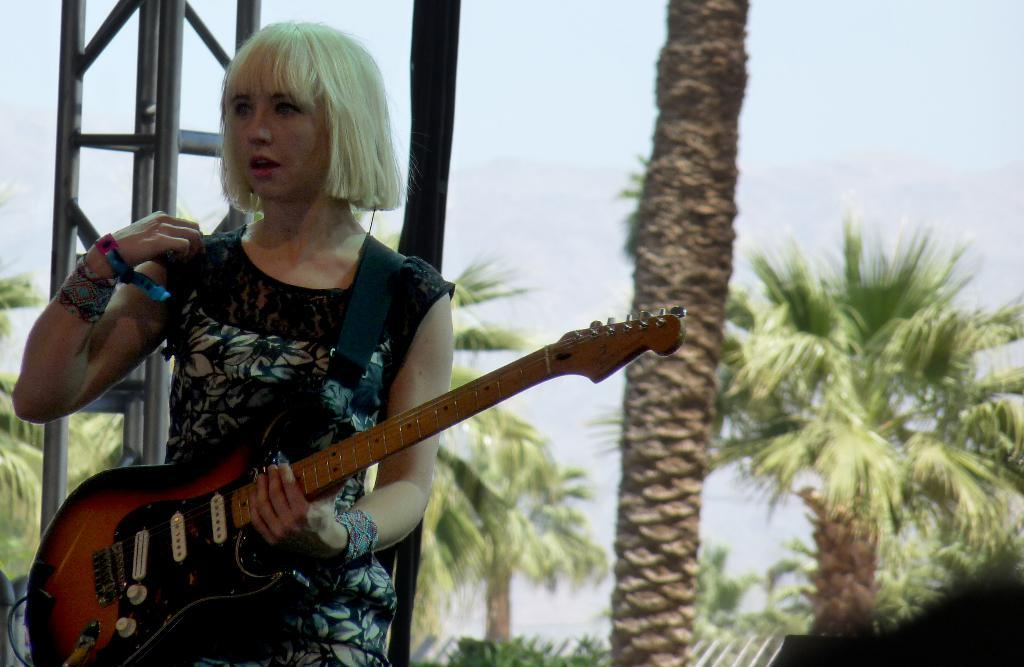What is the woman in the image holding? The woman is holding a guitar. What can be seen in the background of the image? There are trees in the background of the image. What type of poison is the woman using to play the guitar in the image? There is no poison present in the image, and the woman is not using any to play the guitar. What is the price of the guitar the woman is holding in the image? The price of the guitar cannot be determined from the image. --- 